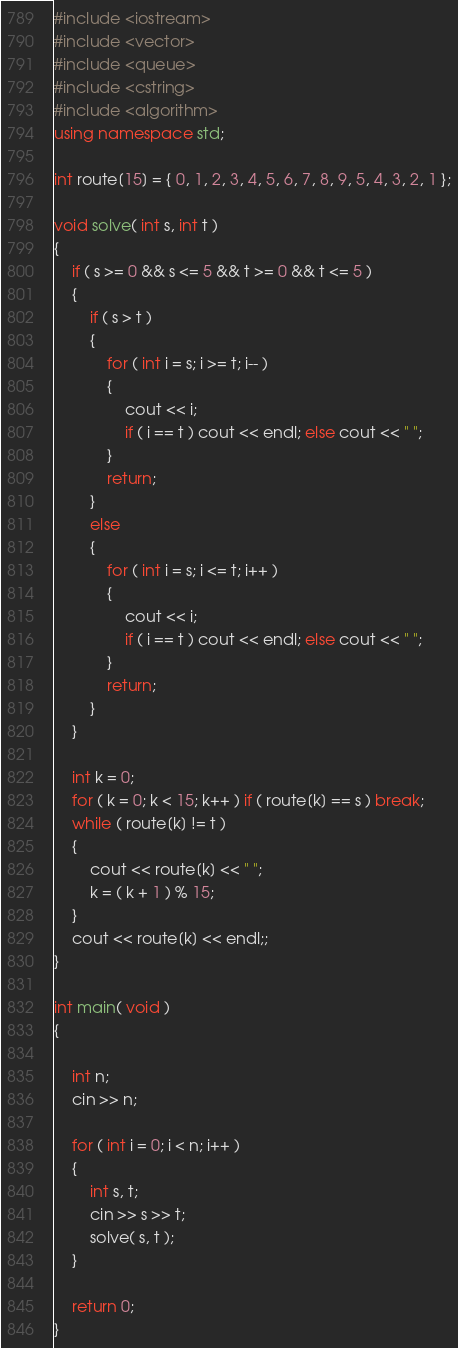Convert code to text. <code><loc_0><loc_0><loc_500><loc_500><_C++_>#include <iostream>
#include <vector>
#include <queue>
#include <cstring>
#include <algorithm>
using namespace std;

int route[15] = { 0, 1, 2, 3, 4, 5, 6, 7, 8, 9, 5, 4, 3, 2, 1 };

void solve( int s, int t )
{
    if ( s >= 0 && s <= 5 && t >= 0 && t <= 5 )
    {
        if ( s > t )
        {
            for ( int i = s; i >= t; i-- )
            {
                cout << i;
                if ( i == t ) cout << endl; else cout << " ";
            }
            return;
        }
        else
        {
            for ( int i = s; i <= t; i++ )
            {
                cout << i;
                if ( i == t ) cout << endl; else cout << " ";
            }
            return;
        }
    }

    int k = 0;
    for ( k = 0; k < 15; k++ ) if ( route[k] == s ) break;
    while ( route[k] != t )
    {
        cout << route[k] << " ";
        k = ( k + 1 ) % 15;
    }
    cout << route[k] << endl;;
}

int main( void )
{

    int n;
    cin >> n;

    for ( int i = 0; i < n; i++ )
    {
        int s, t;
        cin >> s >> t;
        solve( s, t );
    }

    return 0;
}</code> 